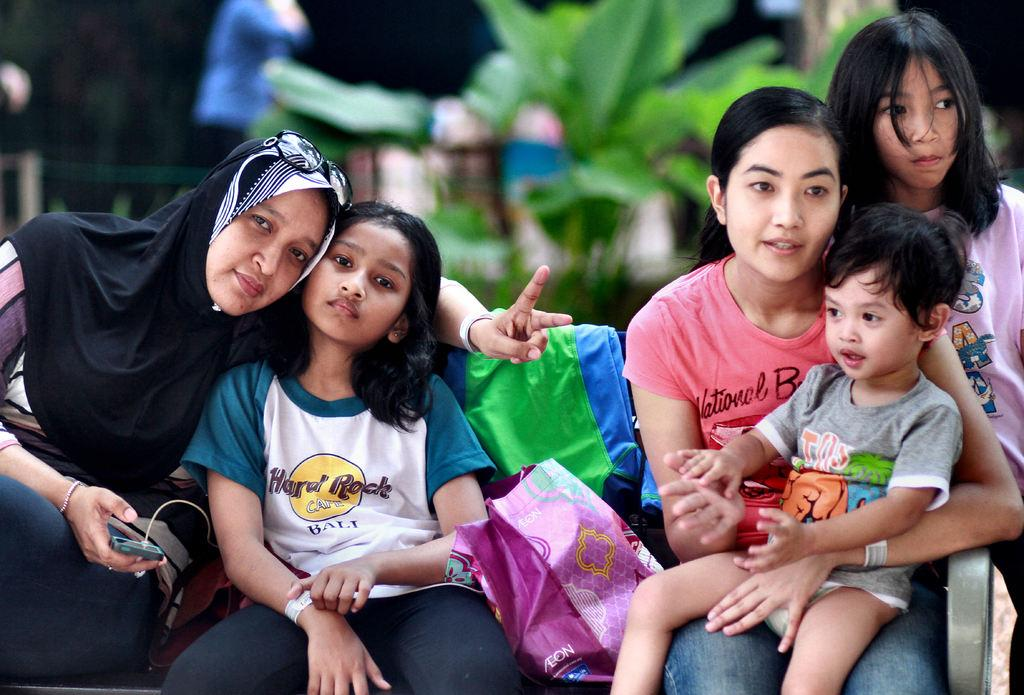How many people are sitting in the image? There are five persons sitting in the image. What is the woman holding in the image? The woman is holding a mobile in the image. Can you describe any other objects in the image? Yes, there is a bag and other objects in the image. What can be said about the background of the image? The background of the image is blurry. What type of drug can be seen in the image? There is no drug present in the image. Is there an iron in the image? There is no iron visible in the image. 